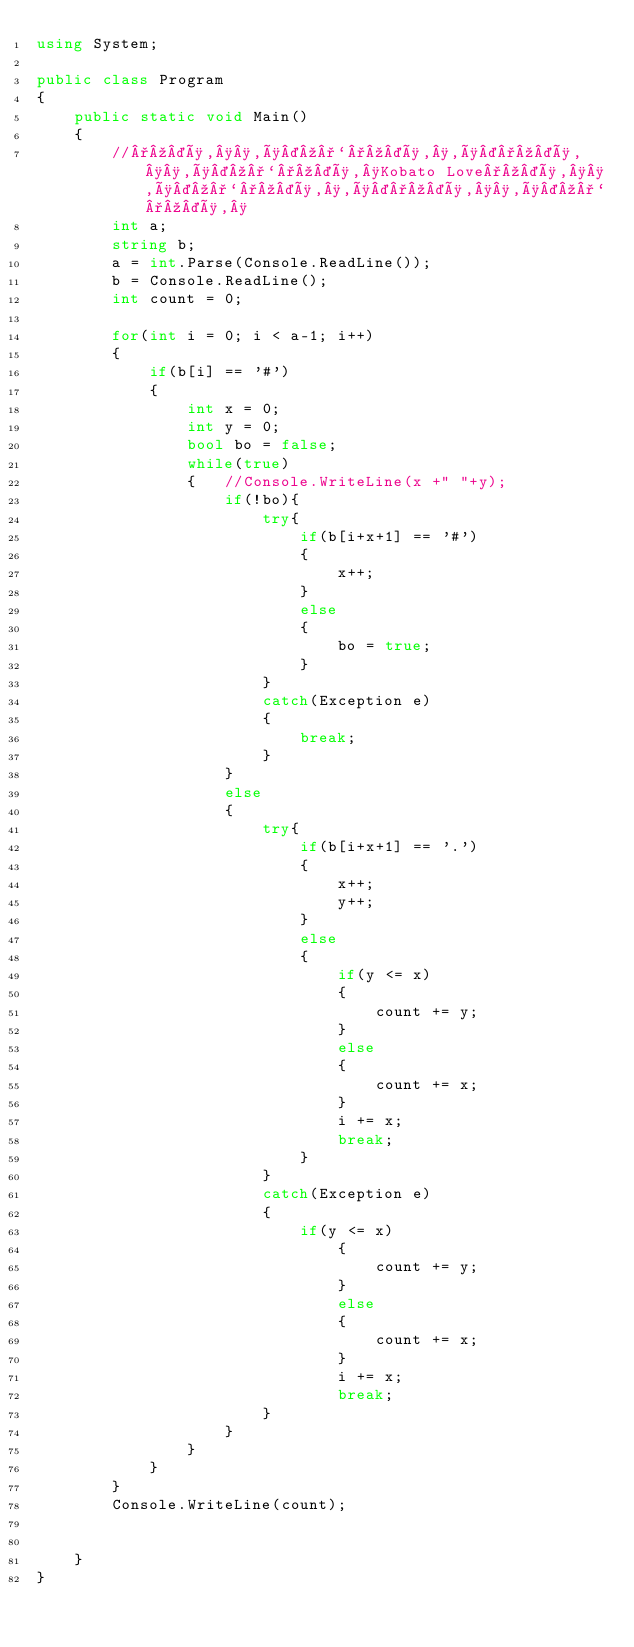Convert code to text. <code><loc_0><loc_0><loc_500><loc_500><_C#_>using System;
					
public class Program
{
	public static void Main()
	{
		//°º¤ø,¸¸,ø¤º°`°º¤ø,¸,ø¤°º¤ø,¸¸,ø¤º°`°º¤ø,¸Kobato Love°º¤ø,¸¸,ø¤º°`°º¤ø,¸,ø¤°º¤ø,¸¸,ø¤º°`°º¤ø,¸
		int a;
		string b;
		a = int.Parse(Console.ReadLine()); 
		b = Console.ReadLine(); 
		int count = 0;
		
		for(int i = 0; i < a-1; i++)
		{
			if(b[i] == '#')
			{
				int x = 0;
				int y = 0;
				bool bo = false;
				while(true)
				{	//Console.WriteLine(x +" "+y);
					if(!bo){
						try{
							if(b[i+x+1] == '#')
							{
								x++;
							}
							else
							{
								bo = true;	
							}
						}
						catch(Exception e)
						{
							break;
						}
					}
					else
					{
						try{
							if(b[i+x+1] == '.')
							{
								x++;
								y++;
							}
							else
							{
								if(y <= x)
								{
									count += y;
								}
								else
								{
									count += x;
								}
								i += x;
								break;
							}
						}
						catch(Exception e)
						{
							if(y <= x)
								{
									count += y;
								}
								else
								{
									count += x;
								}
								i += x;
								break;
						}
					}
				}
			}
		}
		Console.WriteLine(count);
		
		
	}
}
</code> 